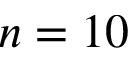<formula> <loc_0><loc_0><loc_500><loc_500>n = 1 0</formula> 